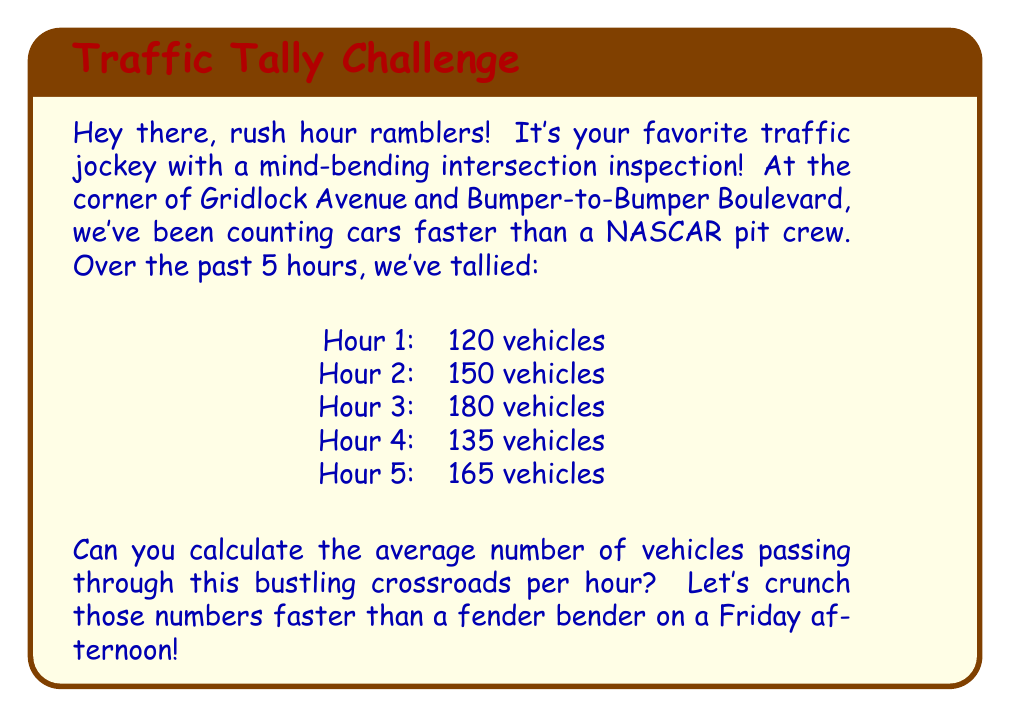Help me with this question. Alright, let's break this down like we're dissecting a traffic jam:

1) First, we need to find the total number of vehicles that passed through the intersection over the 5-hour period. We can do this by adding up the counts for each hour:

   $$ 120 + 150 + 180 + 135 + 165 = 750 \text{ vehicles} $$

2) Now that we have the total number of vehicles, we need to divide this by the number of hours to get the average per hour. The formula for the average (mean) is:

   $$ \text{Average} = \frac{\text{Sum of all values}}{\text{Number of values}} $$

3) In this case:
   
   $$ \text{Average vehicles per hour} = \frac{750 \text{ vehicles}}{5 \text{ hours}} = 150 \text{ vehicles per hour} $$

And there you have it! As smooth as a newly paved highway!
Answer: 150 vehicles per hour 